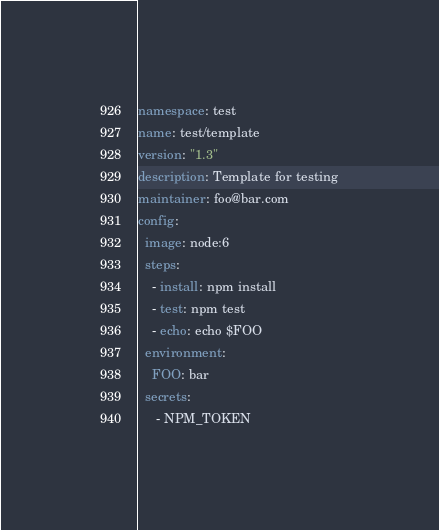<code> <loc_0><loc_0><loc_500><loc_500><_YAML_>namespace: test
name: test/template
version: "1.3"
description: Template for testing
maintainer: foo@bar.com
config:
  image: node:6
  steps:
    - install: npm install
    - test: npm test
    - echo: echo $FOO
  environment:
    FOO: bar
  secrets:
     - NPM_TOKEN
</code> 